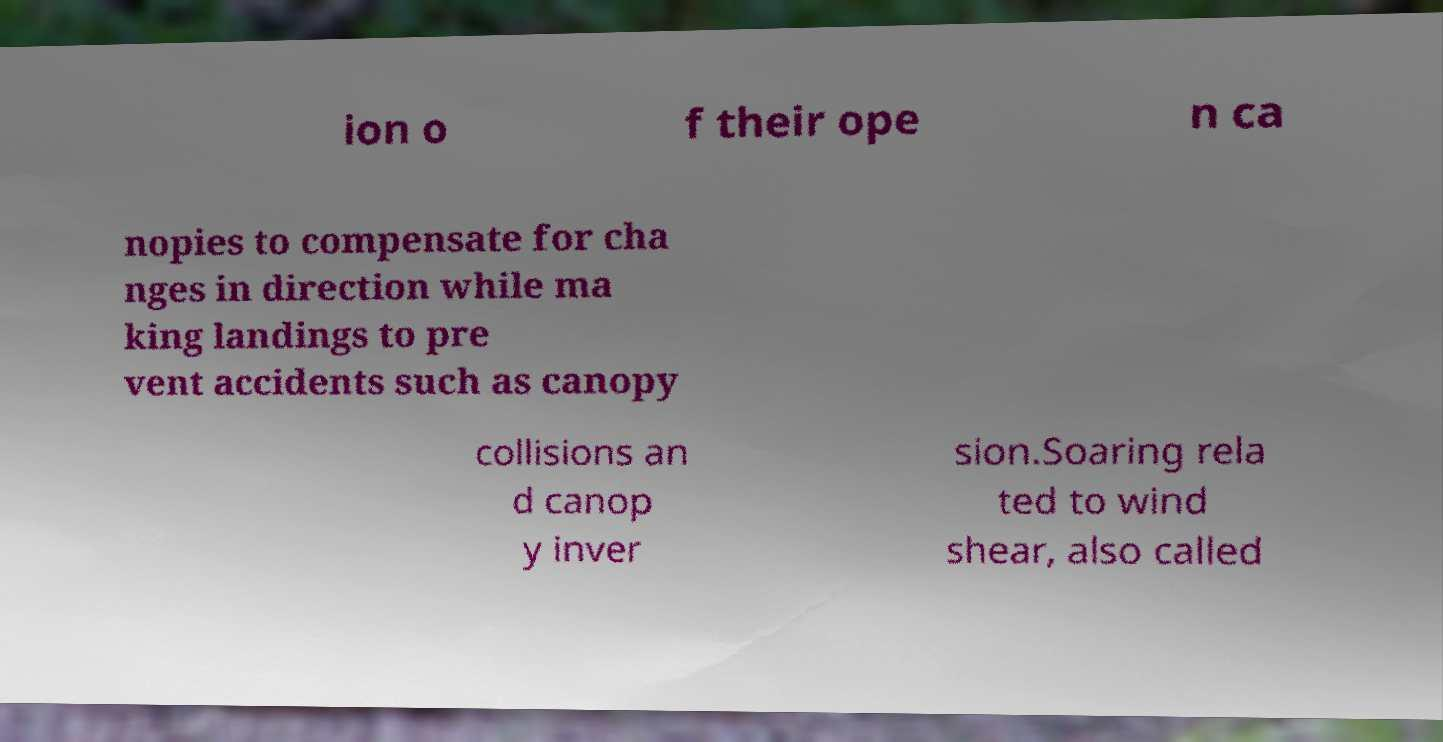Can you accurately transcribe the text from the provided image for me? ion o f their ope n ca nopies to compensate for cha nges in direction while ma king landings to pre vent accidents such as canopy collisions an d canop y inver sion.Soaring rela ted to wind shear, also called 